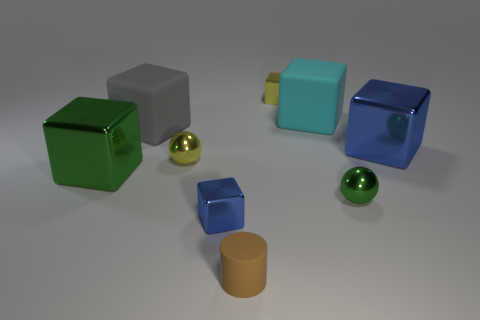Subtract all small metal blocks. How many blocks are left? 4 Add 1 green metal blocks. How many objects exist? 10 Subtract 5 blocks. How many blocks are left? 1 Subtract all yellow blocks. How many blocks are left? 5 Add 1 small green things. How many small green things exist? 2 Subtract 1 green blocks. How many objects are left? 8 Subtract all cubes. How many objects are left? 3 Subtract all gray cylinders. Subtract all purple cubes. How many cylinders are left? 1 Subtract all red cubes. How many yellow balls are left? 1 Subtract all large blue things. Subtract all small brown things. How many objects are left? 7 